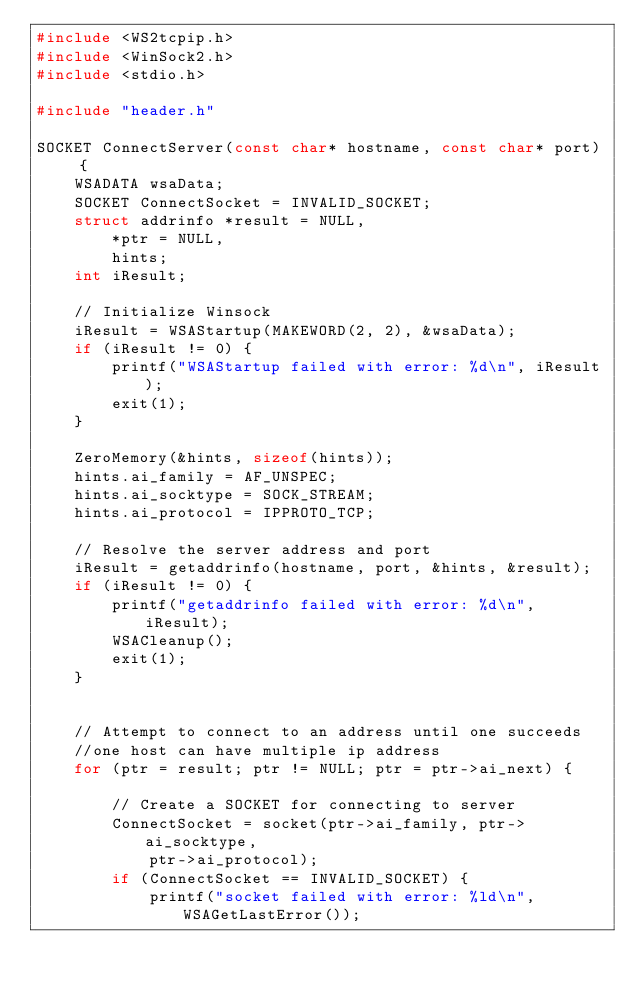<code> <loc_0><loc_0><loc_500><loc_500><_C++_>#include <WS2tcpip.h>
#include <WinSock2.h>
#include <stdio.h>

#include "header.h"

SOCKET ConnectServer(const char* hostname, const char* port) {
	WSADATA wsaData;
	SOCKET ConnectSocket = INVALID_SOCKET;
	struct addrinfo *result = NULL,
		*ptr = NULL,
		hints;
	int iResult;

	// Initialize Winsock
	iResult = WSAStartup(MAKEWORD(2, 2), &wsaData);
	if (iResult != 0) {
		printf("WSAStartup failed with error: %d\n", iResult);
		exit(1);
	}

	ZeroMemory(&hints, sizeof(hints));
	hints.ai_family = AF_UNSPEC;
	hints.ai_socktype = SOCK_STREAM;
	hints.ai_protocol = IPPROTO_TCP;

	// Resolve the server address and port
	iResult = getaddrinfo(hostname, port, &hints, &result);
	if (iResult != 0) {
		printf("getaddrinfo failed with error: %d\n", iResult);
		WSACleanup();
		exit(1);
	}
	

	// Attempt to connect to an address until one succeeds
	//one host can have multiple ip address
	for (ptr = result; ptr != NULL; ptr = ptr->ai_next) {

		// Create a SOCKET for connecting to server
		ConnectSocket = socket(ptr->ai_family, ptr->ai_socktype,
			ptr->ai_protocol);
		if (ConnectSocket == INVALID_SOCKET) {
			printf("socket failed with error: %ld\n", WSAGetLastError());</code> 